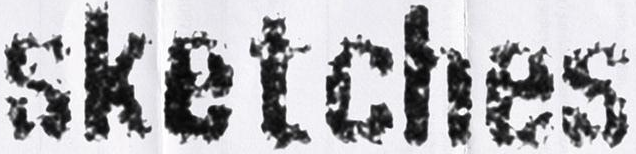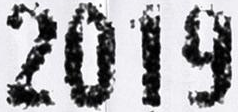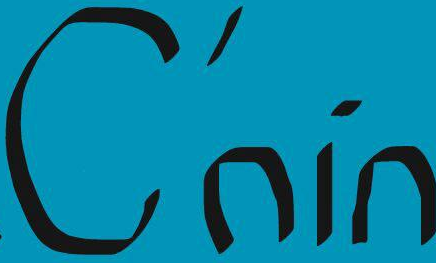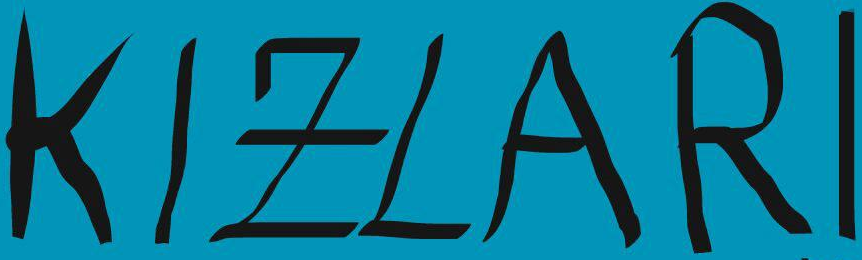What words are shown in these images in order, separated by a semicolon? sketches; 2019; C'nin; KIZLARI 